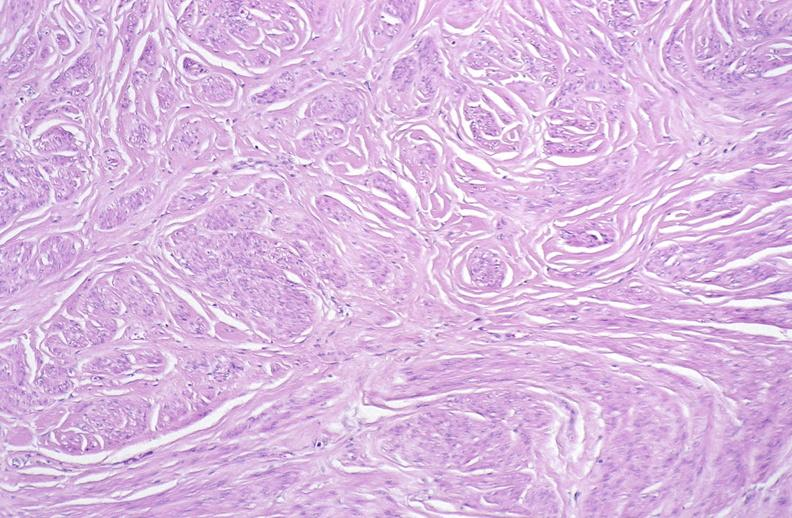what does this image show?
Answer the question using a single word or phrase. Leiomyoma 